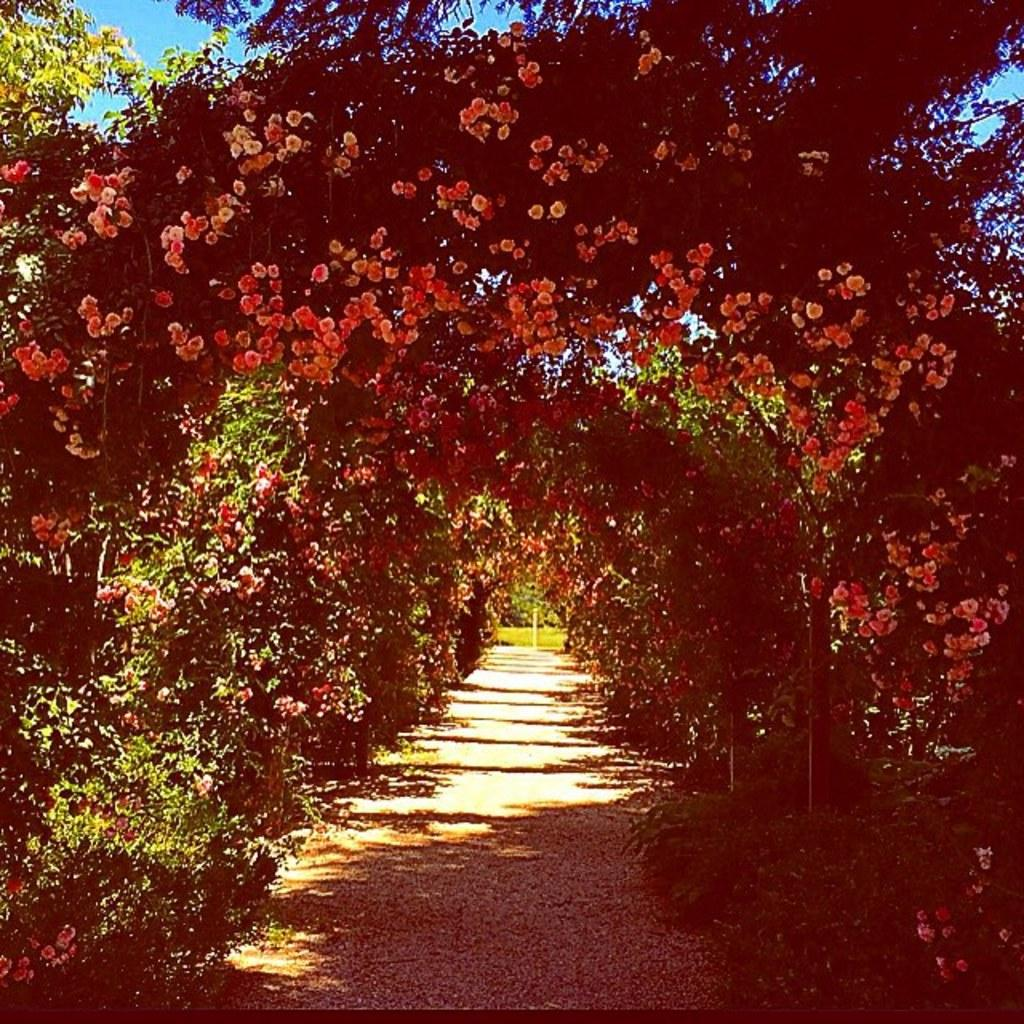What type of outdoor space is depicted in the image? There is a garden in the image. What can be found in the garden? There are plants and flowers in the garden. What is visible at the top of the image? The sky is visible at the top of the image. Can you tell me how many times your aunt has pushed the floor in the image? There is no mention of an aunt or pushing the floor in the image, as it features a garden with plants and flowers. 